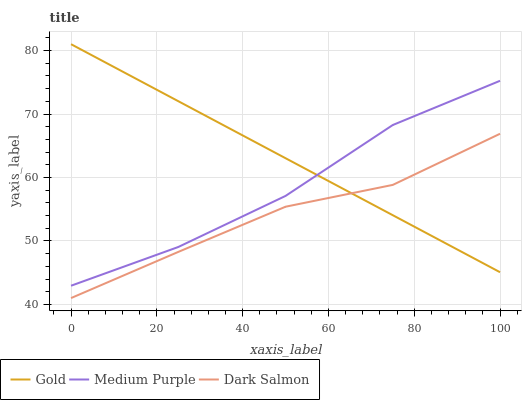Does Dark Salmon have the minimum area under the curve?
Answer yes or no. Yes. Does Gold have the maximum area under the curve?
Answer yes or no. Yes. Does Gold have the minimum area under the curve?
Answer yes or no. No. Does Dark Salmon have the maximum area under the curve?
Answer yes or no. No. Is Gold the smoothest?
Answer yes or no. Yes. Is Medium Purple the roughest?
Answer yes or no. Yes. Is Dark Salmon the smoothest?
Answer yes or no. No. Is Dark Salmon the roughest?
Answer yes or no. No. Does Dark Salmon have the lowest value?
Answer yes or no. Yes. Does Gold have the lowest value?
Answer yes or no. No. Does Gold have the highest value?
Answer yes or no. Yes. Does Dark Salmon have the highest value?
Answer yes or no. No. Is Dark Salmon less than Medium Purple?
Answer yes or no. Yes. Is Medium Purple greater than Dark Salmon?
Answer yes or no. Yes. Does Gold intersect Dark Salmon?
Answer yes or no. Yes. Is Gold less than Dark Salmon?
Answer yes or no. No. Is Gold greater than Dark Salmon?
Answer yes or no. No. Does Dark Salmon intersect Medium Purple?
Answer yes or no. No. 